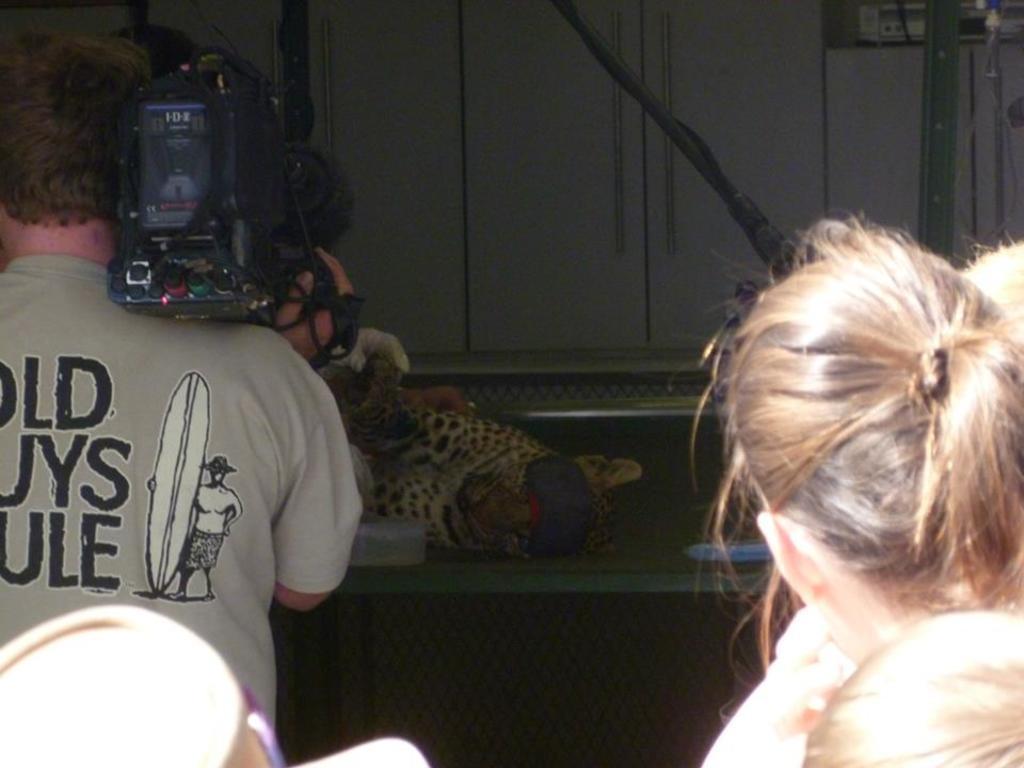How would you summarize this image in a sentence or two? In front of the image there are people. On the left side of the image there is a person holding the camera. In front of him there is a cheetah on the table. There is a mesh. In the background of the image there are pipes on the wall. There is a metal rod and some object. 